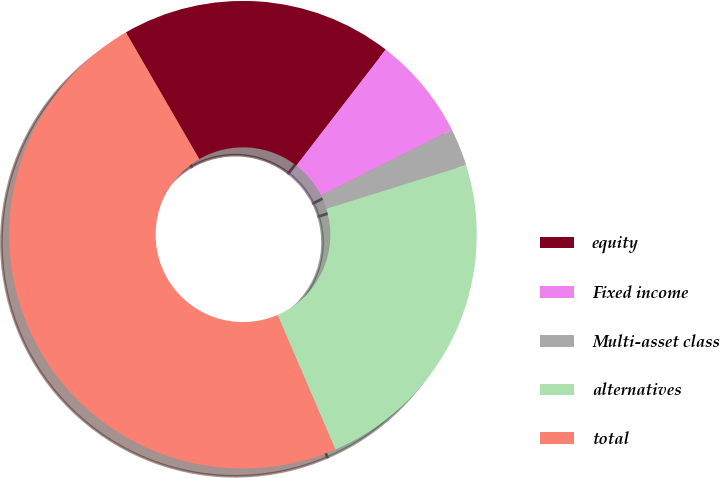Convert chart to OTSL. <chart><loc_0><loc_0><loc_500><loc_500><pie_chart><fcel>equity<fcel>Fixed income<fcel>Multi-asset class<fcel>alternatives<fcel>total<nl><fcel>18.8%<fcel>7.14%<fcel>2.59%<fcel>23.35%<fcel>48.11%<nl></chart> 